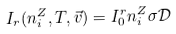Convert formula to latex. <formula><loc_0><loc_0><loc_500><loc_500>I _ { r } ( n _ { i } ^ { Z } , T , \vec { v } ) = I _ { 0 } ^ { r } n _ { i } ^ { Z } \sigma \mathcal { D }</formula> 